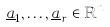Convert formula to latex. <formula><loc_0><loc_0><loc_500><loc_500>\underline { a } _ { 1 } , \dots , \underline { a } _ { r } \in \mathbb { R } ^ { n }</formula> 